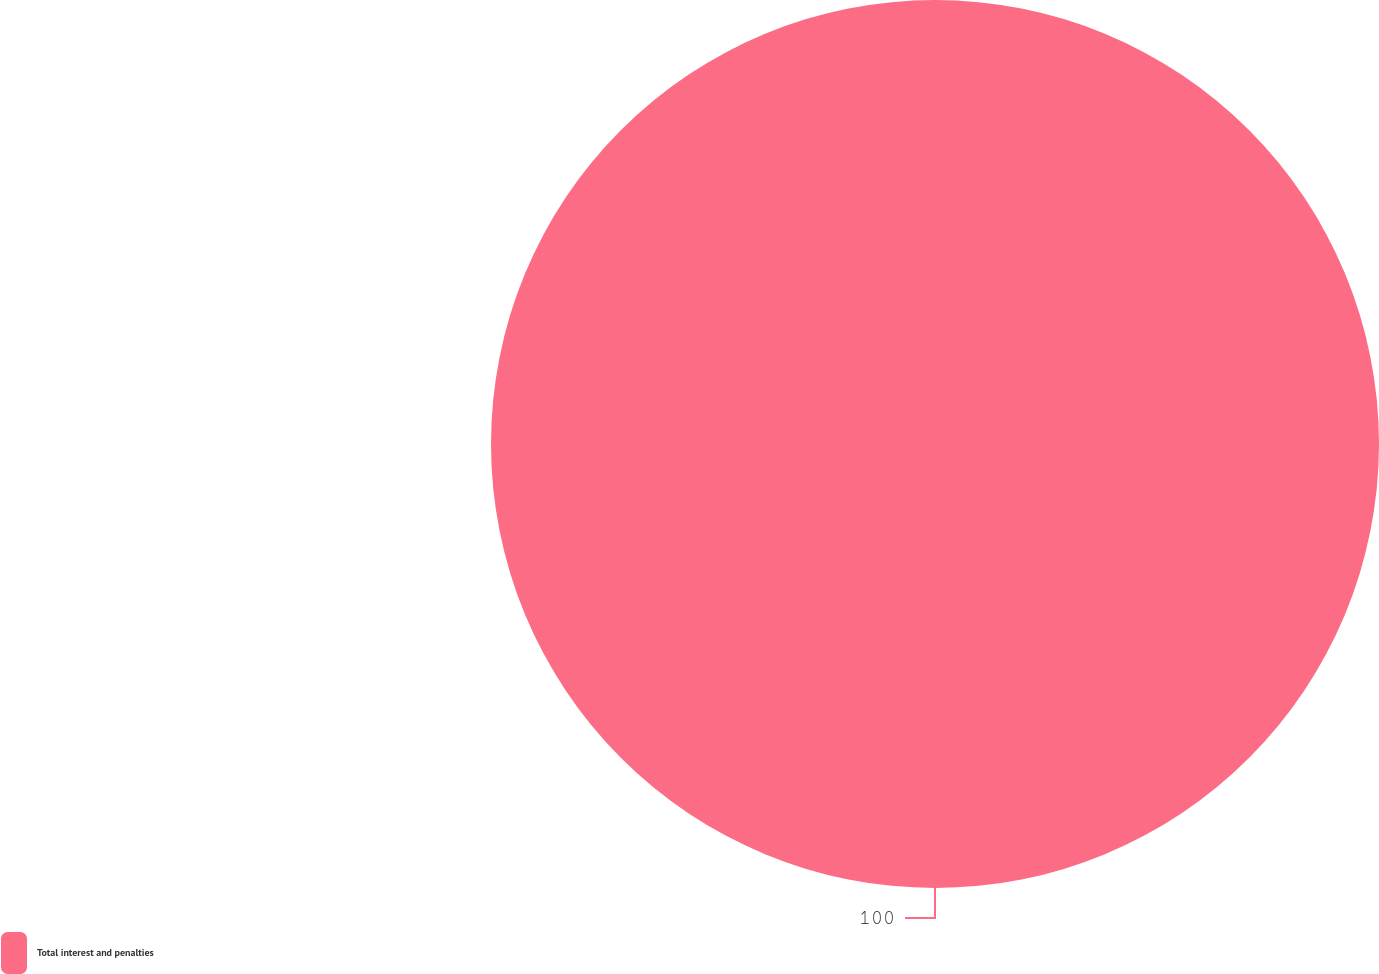Convert chart to OTSL. <chart><loc_0><loc_0><loc_500><loc_500><pie_chart><fcel>Total interest and penalties<nl><fcel>100.0%<nl></chart> 